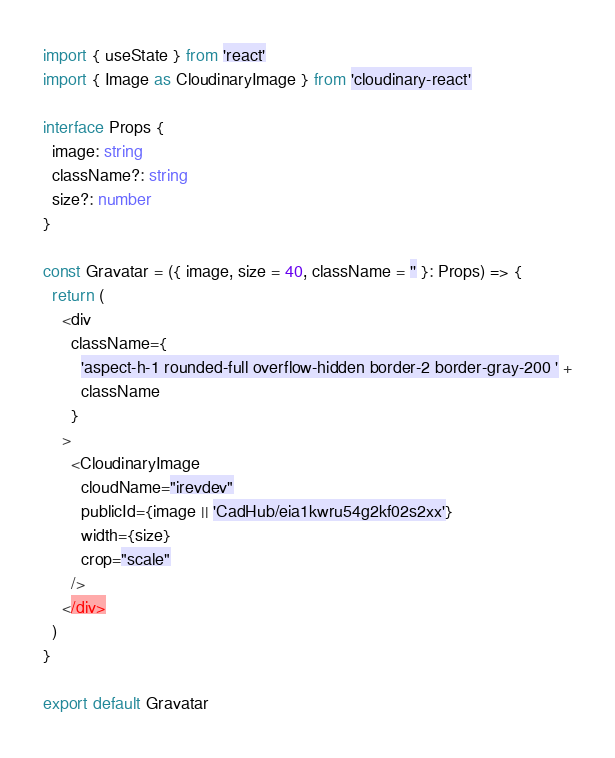<code> <loc_0><loc_0><loc_500><loc_500><_TypeScript_>import { useState } from 'react'
import { Image as CloudinaryImage } from 'cloudinary-react'

interface Props {
  image: string
  className?: string
  size?: number
}

const Gravatar = ({ image, size = 40, className = '' }: Props) => {
  return (
    <div
      className={
        'aspect-h-1 rounded-full overflow-hidden border-2 border-gray-200 ' +
        className
      }
    >
      <CloudinaryImage
        cloudName="irevdev"
        publicId={image || 'CadHub/eia1kwru54g2kf02s2xx'}
        width={size}
        crop="scale"
      />
    </div>
  )
}

export default Gravatar
</code> 